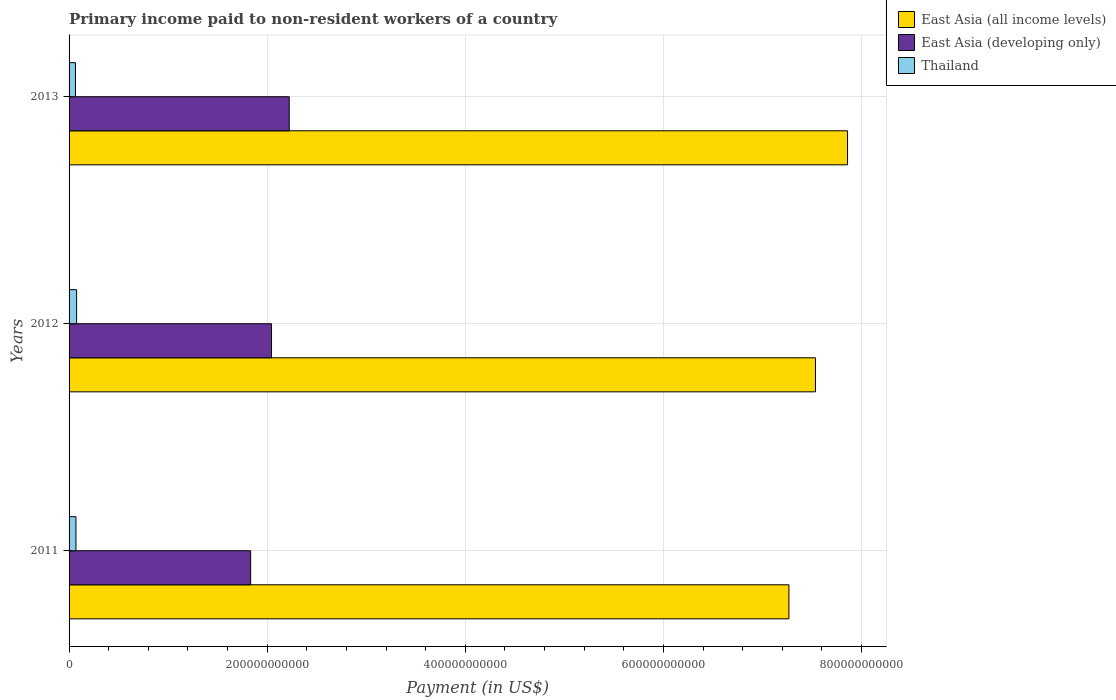How many different coloured bars are there?
Provide a succinct answer. 3. How many groups of bars are there?
Your answer should be compact. 3. Are the number of bars on each tick of the Y-axis equal?
Your answer should be very brief. Yes. How many bars are there on the 3rd tick from the top?
Make the answer very short. 3. What is the label of the 2nd group of bars from the top?
Ensure brevity in your answer.  2012. In how many cases, is the number of bars for a given year not equal to the number of legend labels?
Offer a very short reply. 0. What is the amount paid to workers in Thailand in 2012?
Your answer should be very brief. 7.61e+09. Across all years, what is the maximum amount paid to workers in East Asia (developing only)?
Ensure brevity in your answer.  2.22e+11. Across all years, what is the minimum amount paid to workers in Thailand?
Offer a terse response. 6.42e+09. In which year was the amount paid to workers in East Asia (all income levels) maximum?
Provide a short and direct response. 2013. What is the total amount paid to workers in Thailand in the graph?
Ensure brevity in your answer.  2.10e+1. What is the difference between the amount paid to workers in East Asia (developing only) in 2011 and that in 2012?
Provide a short and direct response. -2.10e+1. What is the difference between the amount paid to workers in Thailand in 2013 and the amount paid to workers in East Asia (developing only) in 2012?
Offer a very short reply. -1.98e+11. What is the average amount paid to workers in Thailand per year?
Give a very brief answer. 6.99e+09. In the year 2013, what is the difference between the amount paid to workers in East Asia (developing only) and amount paid to workers in Thailand?
Ensure brevity in your answer.  2.16e+11. What is the ratio of the amount paid to workers in East Asia (developing only) in 2011 to that in 2013?
Your answer should be compact. 0.82. Is the difference between the amount paid to workers in East Asia (developing only) in 2011 and 2012 greater than the difference between the amount paid to workers in Thailand in 2011 and 2012?
Your answer should be very brief. No. What is the difference between the highest and the second highest amount paid to workers in East Asia (all income levels)?
Provide a short and direct response. 3.24e+1. What is the difference between the highest and the lowest amount paid to workers in Thailand?
Your answer should be very brief. 1.19e+09. In how many years, is the amount paid to workers in Thailand greater than the average amount paid to workers in Thailand taken over all years?
Your response must be concise. 1. What does the 3rd bar from the top in 2013 represents?
Make the answer very short. East Asia (all income levels). What does the 2nd bar from the bottom in 2012 represents?
Offer a terse response. East Asia (developing only). How many bars are there?
Keep it short and to the point. 9. Are all the bars in the graph horizontal?
Make the answer very short. Yes. What is the difference between two consecutive major ticks on the X-axis?
Keep it short and to the point. 2.00e+11. Are the values on the major ticks of X-axis written in scientific E-notation?
Offer a terse response. No. Does the graph contain any zero values?
Keep it short and to the point. No. Does the graph contain grids?
Your answer should be very brief. Yes. How are the legend labels stacked?
Ensure brevity in your answer.  Vertical. What is the title of the graph?
Your response must be concise. Primary income paid to non-resident workers of a country. What is the label or title of the X-axis?
Ensure brevity in your answer.  Payment (in US$). What is the label or title of the Y-axis?
Provide a short and direct response. Years. What is the Payment (in US$) in East Asia (all income levels) in 2011?
Keep it short and to the point. 7.27e+11. What is the Payment (in US$) of East Asia (developing only) in 2011?
Give a very brief answer. 1.83e+11. What is the Payment (in US$) in Thailand in 2011?
Provide a short and direct response. 6.94e+09. What is the Payment (in US$) in East Asia (all income levels) in 2012?
Provide a succinct answer. 7.53e+11. What is the Payment (in US$) in East Asia (developing only) in 2012?
Provide a succinct answer. 2.04e+11. What is the Payment (in US$) of Thailand in 2012?
Your answer should be compact. 7.61e+09. What is the Payment (in US$) of East Asia (all income levels) in 2013?
Offer a very short reply. 7.86e+11. What is the Payment (in US$) of East Asia (developing only) in 2013?
Offer a very short reply. 2.22e+11. What is the Payment (in US$) in Thailand in 2013?
Make the answer very short. 6.42e+09. Across all years, what is the maximum Payment (in US$) of East Asia (all income levels)?
Keep it short and to the point. 7.86e+11. Across all years, what is the maximum Payment (in US$) of East Asia (developing only)?
Provide a succinct answer. 2.22e+11. Across all years, what is the maximum Payment (in US$) in Thailand?
Make the answer very short. 7.61e+09. Across all years, what is the minimum Payment (in US$) in East Asia (all income levels)?
Give a very brief answer. 7.27e+11. Across all years, what is the minimum Payment (in US$) in East Asia (developing only)?
Provide a short and direct response. 1.83e+11. Across all years, what is the minimum Payment (in US$) in Thailand?
Ensure brevity in your answer.  6.42e+09. What is the total Payment (in US$) of East Asia (all income levels) in the graph?
Provide a short and direct response. 2.27e+12. What is the total Payment (in US$) of East Asia (developing only) in the graph?
Offer a terse response. 6.10e+11. What is the total Payment (in US$) in Thailand in the graph?
Ensure brevity in your answer.  2.10e+1. What is the difference between the Payment (in US$) of East Asia (all income levels) in 2011 and that in 2012?
Provide a succinct answer. -2.68e+1. What is the difference between the Payment (in US$) of East Asia (developing only) in 2011 and that in 2012?
Your response must be concise. -2.10e+1. What is the difference between the Payment (in US$) in Thailand in 2011 and that in 2012?
Provide a succinct answer. -6.70e+08. What is the difference between the Payment (in US$) in East Asia (all income levels) in 2011 and that in 2013?
Your answer should be very brief. -5.92e+1. What is the difference between the Payment (in US$) of East Asia (developing only) in 2011 and that in 2013?
Provide a succinct answer. -3.89e+1. What is the difference between the Payment (in US$) of Thailand in 2011 and that in 2013?
Ensure brevity in your answer.  5.16e+08. What is the difference between the Payment (in US$) of East Asia (all income levels) in 2012 and that in 2013?
Give a very brief answer. -3.24e+1. What is the difference between the Payment (in US$) in East Asia (developing only) in 2012 and that in 2013?
Provide a short and direct response. -1.79e+1. What is the difference between the Payment (in US$) of Thailand in 2012 and that in 2013?
Give a very brief answer. 1.19e+09. What is the difference between the Payment (in US$) in East Asia (all income levels) in 2011 and the Payment (in US$) in East Asia (developing only) in 2012?
Keep it short and to the point. 5.22e+11. What is the difference between the Payment (in US$) of East Asia (all income levels) in 2011 and the Payment (in US$) of Thailand in 2012?
Keep it short and to the point. 7.19e+11. What is the difference between the Payment (in US$) in East Asia (developing only) in 2011 and the Payment (in US$) in Thailand in 2012?
Provide a succinct answer. 1.76e+11. What is the difference between the Payment (in US$) of East Asia (all income levels) in 2011 and the Payment (in US$) of East Asia (developing only) in 2013?
Ensure brevity in your answer.  5.04e+11. What is the difference between the Payment (in US$) in East Asia (all income levels) in 2011 and the Payment (in US$) in Thailand in 2013?
Give a very brief answer. 7.20e+11. What is the difference between the Payment (in US$) in East Asia (developing only) in 2011 and the Payment (in US$) in Thailand in 2013?
Make the answer very short. 1.77e+11. What is the difference between the Payment (in US$) of East Asia (all income levels) in 2012 and the Payment (in US$) of East Asia (developing only) in 2013?
Provide a succinct answer. 5.31e+11. What is the difference between the Payment (in US$) in East Asia (all income levels) in 2012 and the Payment (in US$) in Thailand in 2013?
Give a very brief answer. 7.47e+11. What is the difference between the Payment (in US$) in East Asia (developing only) in 2012 and the Payment (in US$) in Thailand in 2013?
Offer a terse response. 1.98e+11. What is the average Payment (in US$) of East Asia (all income levels) per year?
Provide a short and direct response. 7.55e+11. What is the average Payment (in US$) of East Asia (developing only) per year?
Provide a short and direct response. 2.03e+11. What is the average Payment (in US$) in Thailand per year?
Your response must be concise. 6.99e+09. In the year 2011, what is the difference between the Payment (in US$) in East Asia (all income levels) and Payment (in US$) in East Asia (developing only)?
Offer a very short reply. 5.43e+11. In the year 2011, what is the difference between the Payment (in US$) in East Asia (all income levels) and Payment (in US$) in Thailand?
Give a very brief answer. 7.20e+11. In the year 2011, what is the difference between the Payment (in US$) in East Asia (developing only) and Payment (in US$) in Thailand?
Provide a succinct answer. 1.76e+11. In the year 2012, what is the difference between the Payment (in US$) of East Asia (all income levels) and Payment (in US$) of East Asia (developing only)?
Make the answer very short. 5.49e+11. In the year 2012, what is the difference between the Payment (in US$) in East Asia (all income levels) and Payment (in US$) in Thailand?
Give a very brief answer. 7.46e+11. In the year 2012, what is the difference between the Payment (in US$) of East Asia (developing only) and Payment (in US$) of Thailand?
Provide a succinct answer. 1.97e+11. In the year 2013, what is the difference between the Payment (in US$) of East Asia (all income levels) and Payment (in US$) of East Asia (developing only)?
Make the answer very short. 5.64e+11. In the year 2013, what is the difference between the Payment (in US$) in East Asia (all income levels) and Payment (in US$) in Thailand?
Give a very brief answer. 7.79e+11. In the year 2013, what is the difference between the Payment (in US$) in East Asia (developing only) and Payment (in US$) in Thailand?
Offer a terse response. 2.16e+11. What is the ratio of the Payment (in US$) in East Asia (all income levels) in 2011 to that in 2012?
Give a very brief answer. 0.96. What is the ratio of the Payment (in US$) in East Asia (developing only) in 2011 to that in 2012?
Your response must be concise. 0.9. What is the ratio of the Payment (in US$) of Thailand in 2011 to that in 2012?
Provide a short and direct response. 0.91. What is the ratio of the Payment (in US$) of East Asia (all income levels) in 2011 to that in 2013?
Your answer should be compact. 0.92. What is the ratio of the Payment (in US$) of East Asia (developing only) in 2011 to that in 2013?
Your response must be concise. 0.82. What is the ratio of the Payment (in US$) in Thailand in 2011 to that in 2013?
Keep it short and to the point. 1.08. What is the ratio of the Payment (in US$) of East Asia (all income levels) in 2012 to that in 2013?
Your response must be concise. 0.96. What is the ratio of the Payment (in US$) in East Asia (developing only) in 2012 to that in 2013?
Make the answer very short. 0.92. What is the ratio of the Payment (in US$) of Thailand in 2012 to that in 2013?
Your answer should be compact. 1.18. What is the difference between the highest and the second highest Payment (in US$) in East Asia (all income levels)?
Offer a very short reply. 3.24e+1. What is the difference between the highest and the second highest Payment (in US$) of East Asia (developing only)?
Provide a short and direct response. 1.79e+1. What is the difference between the highest and the second highest Payment (in US$) in Thailand?
Keep it short and to the point. 6.70e+08. What is the difference between the highest and the lowest Payment (in US$) of East Asia (all income levels)?
Offer a terse response. 5.92e+1. What is the difference between the highest and the lowest Payment (in US$) in East Asia (developing only)?
Ensure brevity in your answer.  3.89e+1. What is the difference between the highest and the lowest Payment (in US$) of Thailand?
Offer a terse response. 1.19e+09. 